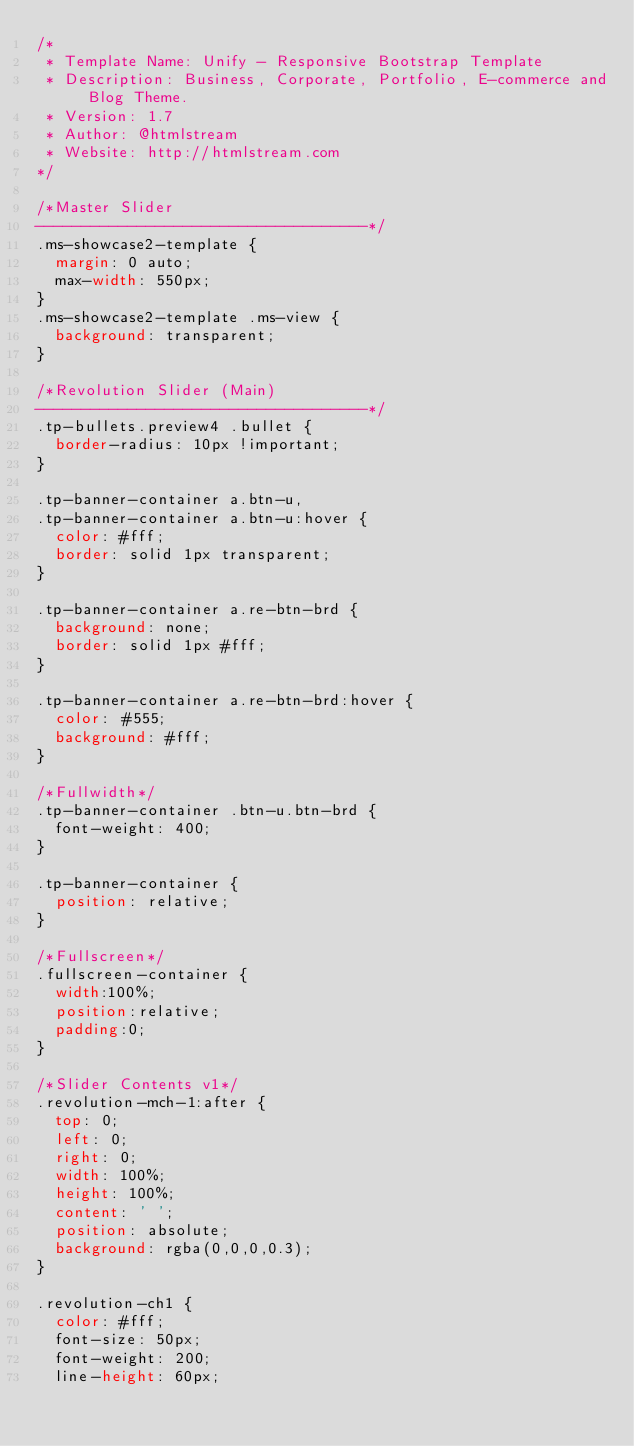Convert code to text. <code><loc_0><loc_0><loc_500><loc_500><_CSS_>/*   
 * Template Name: Unify - Responsive Bootstrap Template
 * Description: Business, Corporate, Portfolio, E-commerce and Blog Theme.
 * Version: 1.7
 * Author: @htmlstream
 * Website: http://htmlstream.com
*/

/*Master Slider
------------------------------------*/
.ms-showcase2-template { 
  margin: 0 auto;
  max-width: 550px; 
}
.ms-showcase2-template .ms-view { 
  background: transparent;
}

/*Revolution Slider (Main)
------------------------------------*/
.tp-bullets.preview4 .bullet {
  border-radius: 10px !important;
}

.tp-banner-container a.btn-u,
.tp-banner-container a.btn-u:hover {
  color: #fff;
  border: solid 1px transparent;
}

.tp-banner-container a.re-btn-brd {
  background: none;
  border: solid 1px #fff;
}

.tp-banner-container a.re-btn-brd:hover {
  color: #555;
  background: #fff; 
}

/*Fullwidth*/
.tp-banner-container .btn-u.btn-brd {
  font-weight: 400;
}

.tp-banner-container {
  position: relative;
}

/*Fullscreen*/
.fullscreen-container {
  width:100%;
  position:relative;
  padding:0;
}

/*Slider Contents v1*/
.revolution-mch-1:after {
  top: 0;
  left: 0;
  right: 0;
  width: 100%;
  height: 100%;
  content: ' ';
  position: absolute;
  background: rgba(0,0,0,0.3);
} 

.revolution-ch1 {
  color: #fff;
  font-size: 50px;
  font-weight: 200;
  line-height: 60px;</code> 